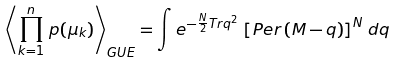<formula> <loc_0><loc_0><loc_500><loc_500>\left \langle \prod _ { k = 1 } ^ { n } \, p ( \mu _ { k } ) \right \rangle _ { G U E } = \int e ^ { - \frac { N } { 2 } T r { q } ^ { 2 } } \, \left [ P e r \left ( { M } - { q } \right ) \right ] ^ { N } \, d { q }</formula> 